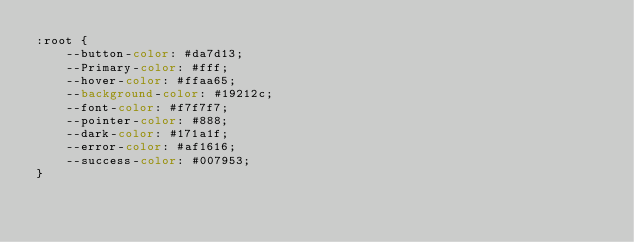<code> <loc_0><loc_0><loc_500><loc_500><_CSS_>:root {
    --button-color: #da7d13;
    --Primary-color: #fff;
    --hover-color: #ffaa65;
    --background-color: #19212c;
    --font-color: #f7f7f7;
    --pointer-color: #888;
    --dark-color: #171a1f;
    --error-color: #af1616;
    --success-color: #007953;
}
</code> 